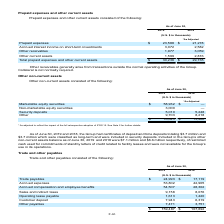According to Atlassian Plc's financial document, As of June 30, 2019, what is the amount of certificates of deposit and time deposits? According to the financial document, $3.7 million. The relevant text states: "certificates of deposit and time deposits totaling $3.7 million and certificates of deposit and time deposits totaling $3.7 million and..." Also, What was the adjustment done to figures in 2018? to reflect the impact of the full retrospective adoption of IFRS 15. The document states: "* As adjusted to reflect the impact of the full retrospective adoption of IFRS 15. See Note 2 for further details...." Also, What is the total amount of non-current assets as of June 30, 2019? According to the financial document, $76,645 (in thousands). The relevant text states: "$ 76,645 $ 13,466..." Also, can you calculate: What is the change in value between security deposits between fiscal years 2018 and 2019? Based on the calculation: 5,010-5,248, the result is -238 (in thousands). This is based on the information: "Security deposits 5,010 5,248 Security deposits 5,010 5,248..." The key data points involved are: 5,010, 5,248. Also, can you calculate: What is the percentage difference of security deposits between fiscal years 2018 and 2019? To answer this question, I need to perform calculations using the financial data. The calculation is: (5,010-5,248)/5,248, which equals -4.54 (percentage). This is based on the information: "Security deposits 5,010 5,248 Security deposits 5,010 5,248..." The key data points involved are: 5,010, 5,248. Also, can you calculate: What is the percentage constitution of marketable equity securities among the total non-current assets in fiscal year 2019? Based on the calculation: 58,932/76,645, the result is 76.89 (percentage). This is based on the information: "Marketable equity securities $ 58,932 $ — $ 76,645 $ 13,466..." The key data points involved are: 58,932, 76,645. 